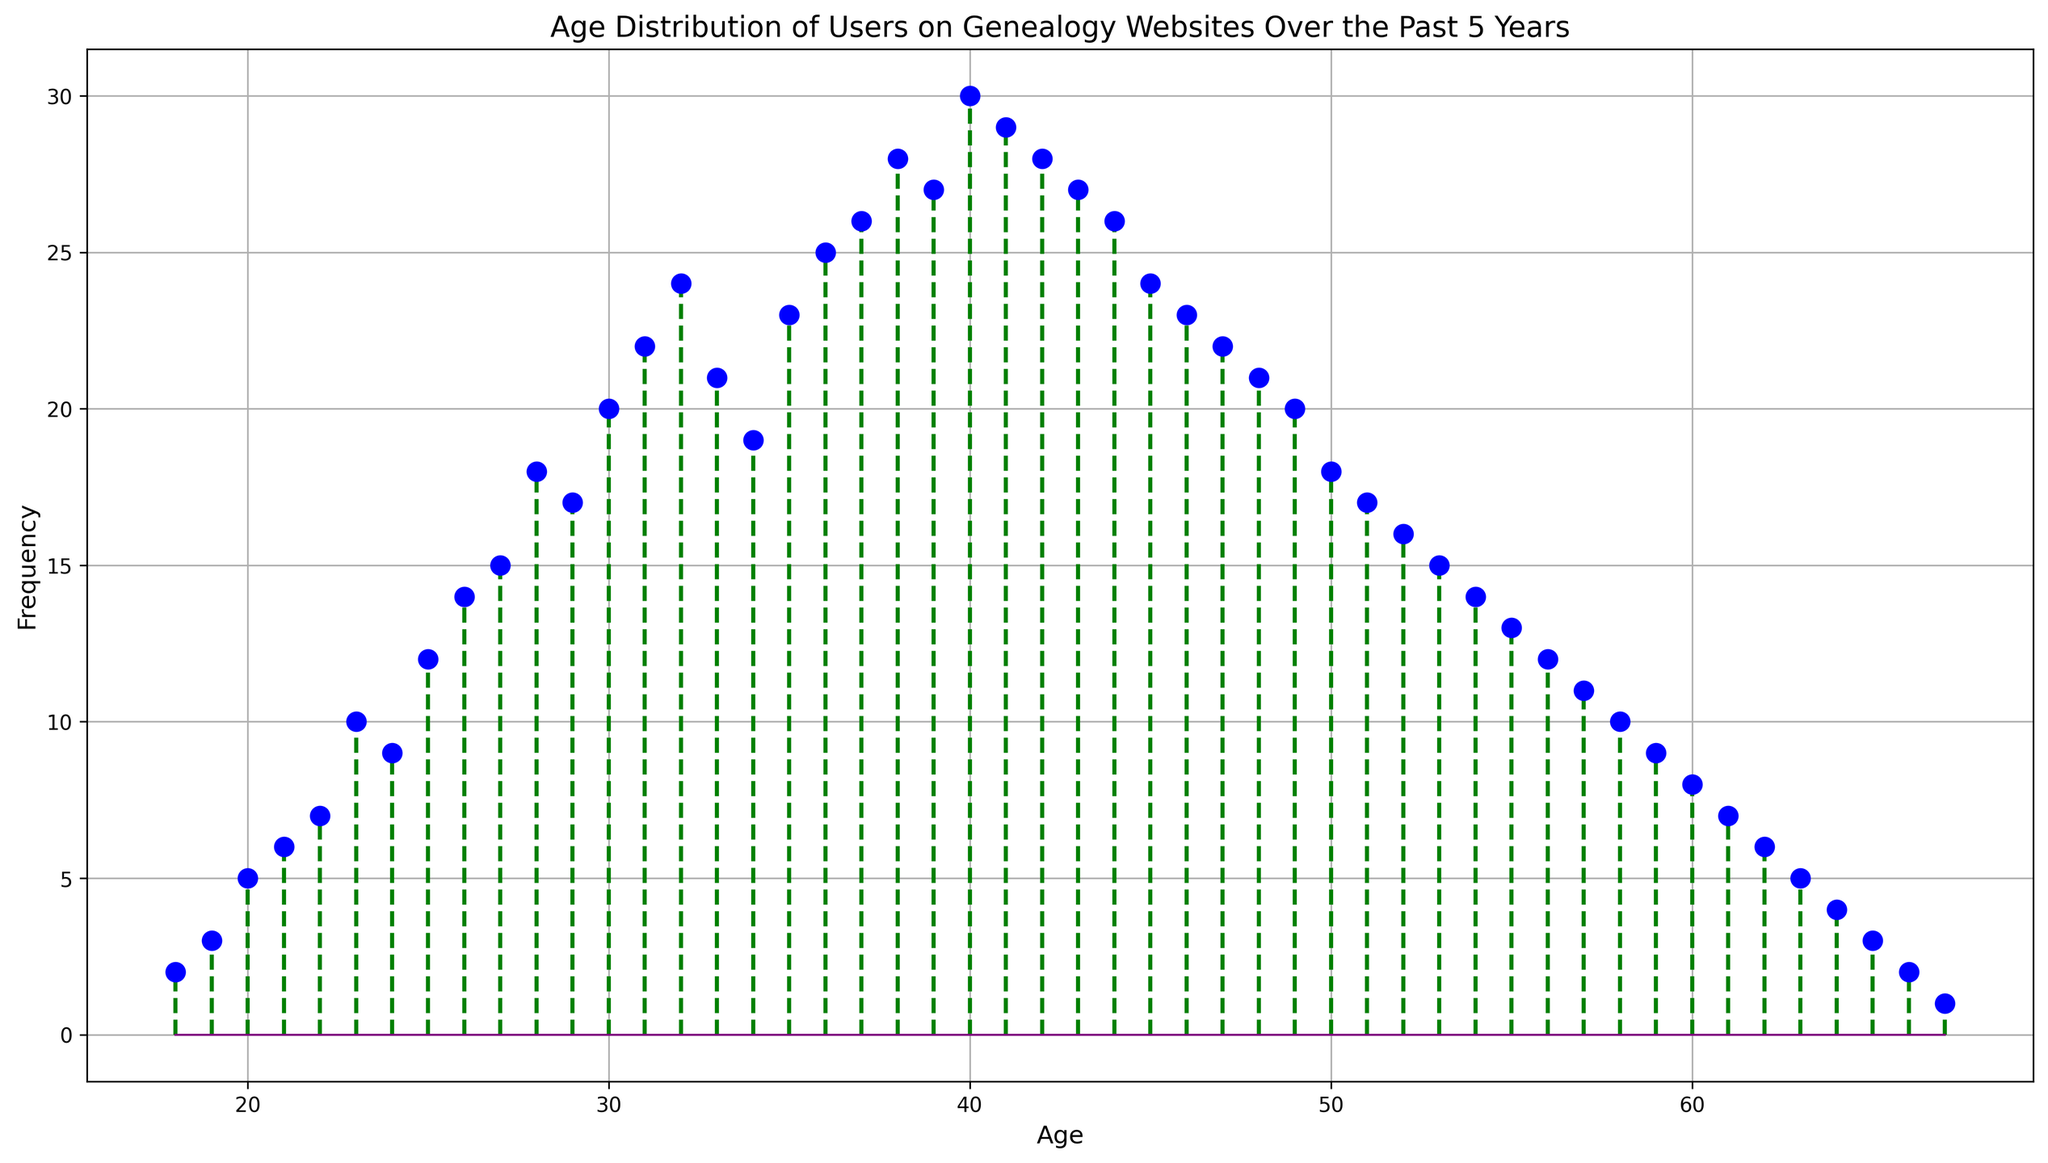What's the age of the users with the highest frequency? The highest point on the stem plot indicates the age with the highest frequency. The frequency is highest at 40.
Answer: 40 How does the frequency of users aged 25 compare to those aged 23? By comparing the heights of the stem lines for ages 25 and 23, the line for age 25 is slightly higher than for age 23.
Answer: 25 > 23 What is the average frequency of users aged between 30 and 40? Sum the frequencies for ages 30 to 40: 20 + 22 + 24 + 21 + 19 + 23 + 25 + 26 + 28 + 27 + 30 = 265. There are 11 data points. So, the average is 265/11.
Answer: 24.09 Is there an age where the user frequency is equal to 27? If yes, what age is it? Look for age(s) where the stem line reaches 27. Both ages 39 and 43 have a frequency of 27.
Answer: 39 and 43 Which age has a frequency that is visually represented by green stem lines? All frequencies are visually represented by green stem lines connecting the ages on the x-axis to markers on the y-axis. This applies to all ages.
Answer: All ages What is the difference in frequency between the youngest and oldest age groups? The frequency for age 18 (youngest) is 2, and for age 67 (oldest) is 1. The difference 2 - 1 = 1.
Answer: 1 How many ages have a frequency greater than 20? By observing the stem plot, count the ages where the frequency marker surpasses 20. Ages are 30, 31, 32, 35, 36, 37, 38, 39, 40, 41. There are 10 ages.
Answer: 10 At what frequency does the baseline change color? The baseline color is purple, and it doesn't change across the figure. It remains consistent.
Answer: Does not change For what ages is the frequency evenly falling between the age intervals of 18 to 67? The plot shows a trend in the frequency where peaks are on either side of age 40 but not evenly falling between all age intervals.
Answer: Not evenly falling Does the stem plot have any symmetrical patterns? Observing the plot, there is a rough symmetry around age 40, with frequencies tapering down on either side.
Answer: Around age 40 